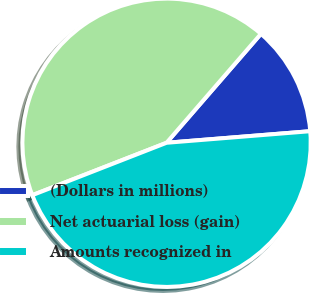Convert chart to OTSL. <chart><loc_0><loc_0><loc_500><loc_500><pie_chart><fcel>(Dollars in millions)<fcel>Net actuarial loss (gain)<fcel>Amounts recognized in<nl><fcel>12.36%<fcel>42.29%<fcel>45.36%<nl></chart> 